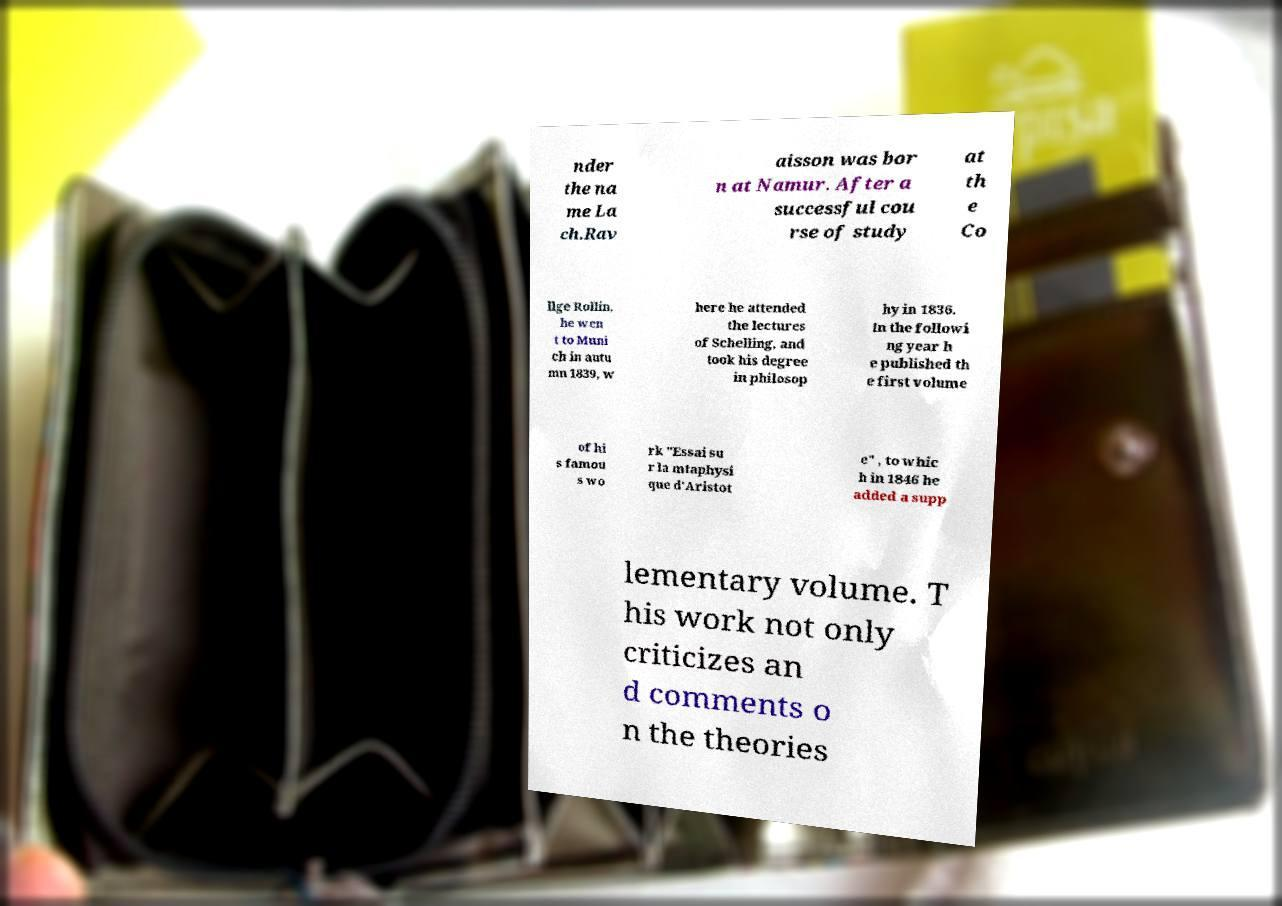Please identify and transcribe the text found in this image. nder the na me La ch.Rav aisson was bor n at Namur. After a successful cou rse of study at th e Co llge Rollin, he wen t to Muni ch in autu mn 1839, w here he attended the lectures of Schelling, and took his degree in philosop hy in 1836. In the followi ng year h e published th e first volume of hi s famou s wo rk "Essai su r la mtaphysi que d'Aristot e" , to whic h in 1846 he added a supp lementary volume. T his work not only criticizes an d comments o n the theories 